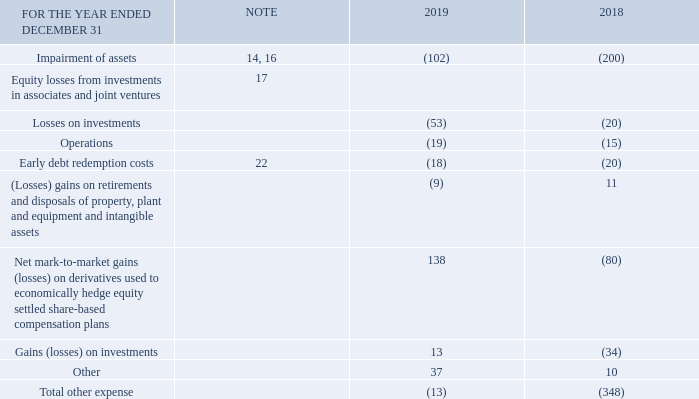Note 7 Other expense
Impairment of Assets
2019
Impairment charges in 2019 included $85 million allocated to indefinite-life intangible assets, and $8 million allocated primarily to property, plant and equipment. These impairment charges relate to broadcast licences and certain assets for various radio markets within our Bell Media segment. The impairment charges were a result of continued advertising demand and ratings pressures in the industry resulting from audience declines, as well as competitive pressure from streaming services. The charges were determined by comparing the carrying value of the CGUs to their fair value less cost of disposal. We estimated the fair value of the CGUs using both discounted cash flows and market-based valuation models, which include five-year cash flow projections derived from business plans reviewed by senior management for the period of January 1, 2020 to December 31, 2024, using a discount rate of 7.5% and a perpetuity growth rate of nil as well as market multiple data from public companies and market transactions. The carrying value of these CGUs was $464 million at December 31, 2019.
2018
Impairment charges in  2018 included $145  million allocated to indefinite-life intangible assets, and $14 million allocated to finite-life intangible assets. These impairment charges primarily relate to our French TV channels within our Bell Media segment. These impairments were the result of revenue and profitability declines from lower audience levels and subscriber erosion. The charges were determined by comparing the carrying value of the CGUs to their fair value less costs of disposal. We estimated the fair value of the CGUs using both discounted cash flows and market-based valuation models, which include five-year cash flow projections derived from business plans reviewed by senior management for the period of January 1, 2019 to December 31, 2023, using a discount rate of 8.0% to 8.5% and a perpetuity growth rate of nil, as well as market multiple data from public companies and market transactions. The carrying value of these CGUs was $515 million at December 31, 2018. In the previous year’s impairment analysis, the company’s French Pay and French Specialty TV channels were tested for recoverability separately. In 2018, the CGUs were grouped to form one French CGU which reflects the evolution of the cash flows from our content strategies as well as the CRTC beginning to regulate Canadian broadcasters under a group licence approach based on language.
Additionally, in 2018, we recorded an indefinite-life intangible asset impairment charge of $31 million within our Bell Media segment as a result of a strategic decision to retire a brand.
EQUITY LOSSES FROM INVESTMENTS IN ASSOCIATES AND JOINT VENTURES
We recorded a loss on investment of $53 million and $20 million in 2019 and 2018, respectively, related to equity losses on our share of an obligation to repurchase at fair value the minority interest in one of BCE’s joint ventures. The obligation is marked to market each reporting period and the gain or loss on investment is recorded as equity gains or losses from investments in associates and joint ventures.
GAINS (LOSSES) ON INVESTMENTS
In 2019 we recorded gains of $13 million which included a gain on an obligation to repurchase at fair value the minority interest in one of our subsidiaries.
In 2018, we recorded losses of $34 million which included a loss on an obligation to repurchase at fair value the minority interest in one of our subsidiaries.
What is the amount of gains (losses) on investments in 2019?
Answer scale should be: million. 13. What is the Impairment of assets for 2019?
Answer scale should be: million. (102). What are the losses on investment recorded in 2019 and 2018 related to? Equity losses on our share of an obligation to repurchase at fair value the minority interest in one of bce’s joint ventures. What is the change in the impairment of assets?
Answer scale should be: million. -102-(-200)
Answer: 98. What is the total amount of equity losses from investments in associates and joint ventures in 2019?
Answer scale should be: million. -53+(-19)
Answer: -72. What is the total amount of 'Other' for 2018 and 2019?
Answer scale should be: million. 37+10
Answer: 47. 